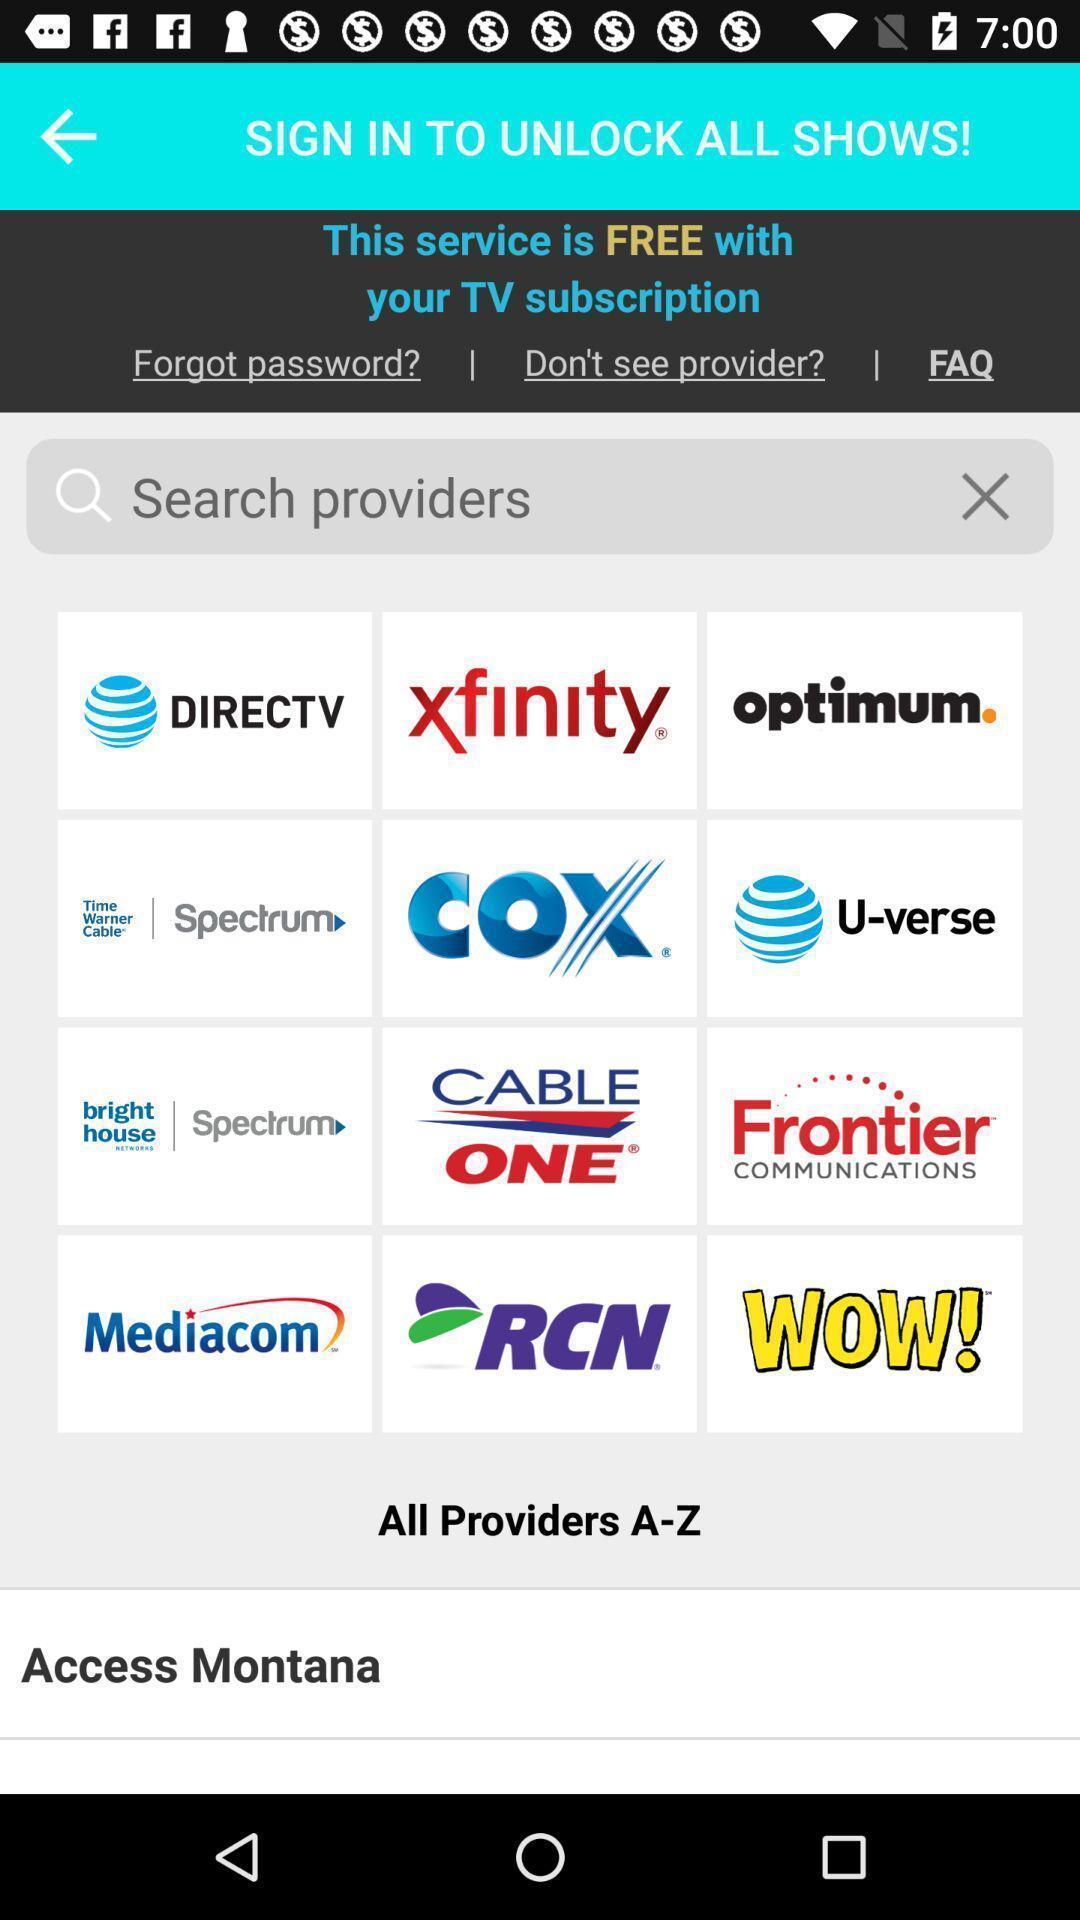Explain the elements present in this screenshot. Sign in page to unlock all shows. 